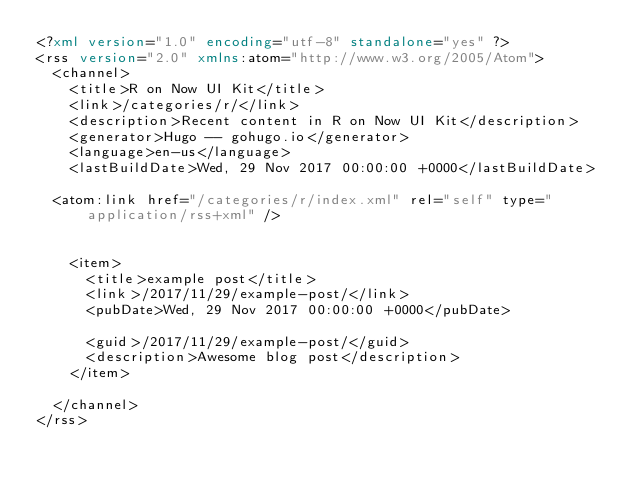<code> <loc_0><loc_0><loc_500><loc_500><_XML_><?xml version="1.0" encoding="utf-8" standalone="yes" ?>
<rss version="2.0" xmlns:atom="http://www.w3.org/2005/Atom">
  <channel>
    <title>R on Now UI Kit</title>
    <link>/categories/r/</link>
    <description>Recent content in R on Now UI Kit</description>
    <generator>Hugo -- gohugo.io</generator>
    <language>en-us</language>
    <lastBuildDate>Wed, 29 Nov 2017 00:00:00 +0000</lastBuildDate>
    
	<atom:link href="/categories/r/index.xml" rel="self" type="application/rss+xml" />
    
    
    <item>
      <title>example post</title>
      <link>/2017/11/29/example-post/</link>
      <pubDate>Wed, 29 Nov 2017 00:00:00 +0000</pubDate>
      
      <guid>/2017/11/29/example-post/</guid>
      <description>Awesome blog post</description>
    </item>
    
  </channel>
</rss></code> 